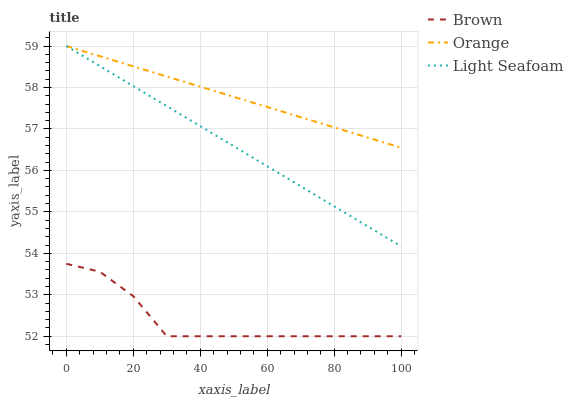Does Brown have the minimum area under the curve?
Answer yes or no. Yes. Does Orange have the maximum area under the curve?
Answer yes or no. Yes. Does Light Seafoam have the minimum area under the curve?
Answer yes or no. No. Does Light Seafoam have the maximum area under the curve?
Answer yes or no. No. Is Light Seafoam the smoothest?
Answer yes or no. Yes. Is Brown the roughest?
Answer yes or no. Yes. Is Brown the smoothest?
Answer yes or no. No. Is Light Seafoam the roughest?
Answer yes or no. No. Does Brown have the lowest value?
Answer yes or no. Yes. Does Light Seafoam have the lowest value?
Answer yes or no. No. Does Light Seafoam have the highest value?
Answer yes or no. Yes. Does Brown have the highest value?
Answer yes or no. No. Is Brown less than Orange?
Answer yes or no. Yes. Is Light Seafoam greater than Brown?
Answer yes or no. Yes. Does Orange intersect Light Seafoam?
Answer yes or no. Yes. Is Orange less than Light Seafoam?
Answer yes or no. No. Is Orange greater than Light Seafoam?
Answer yes or no. No. Does Brown intersect Orange?
Answer yes or no. No. 